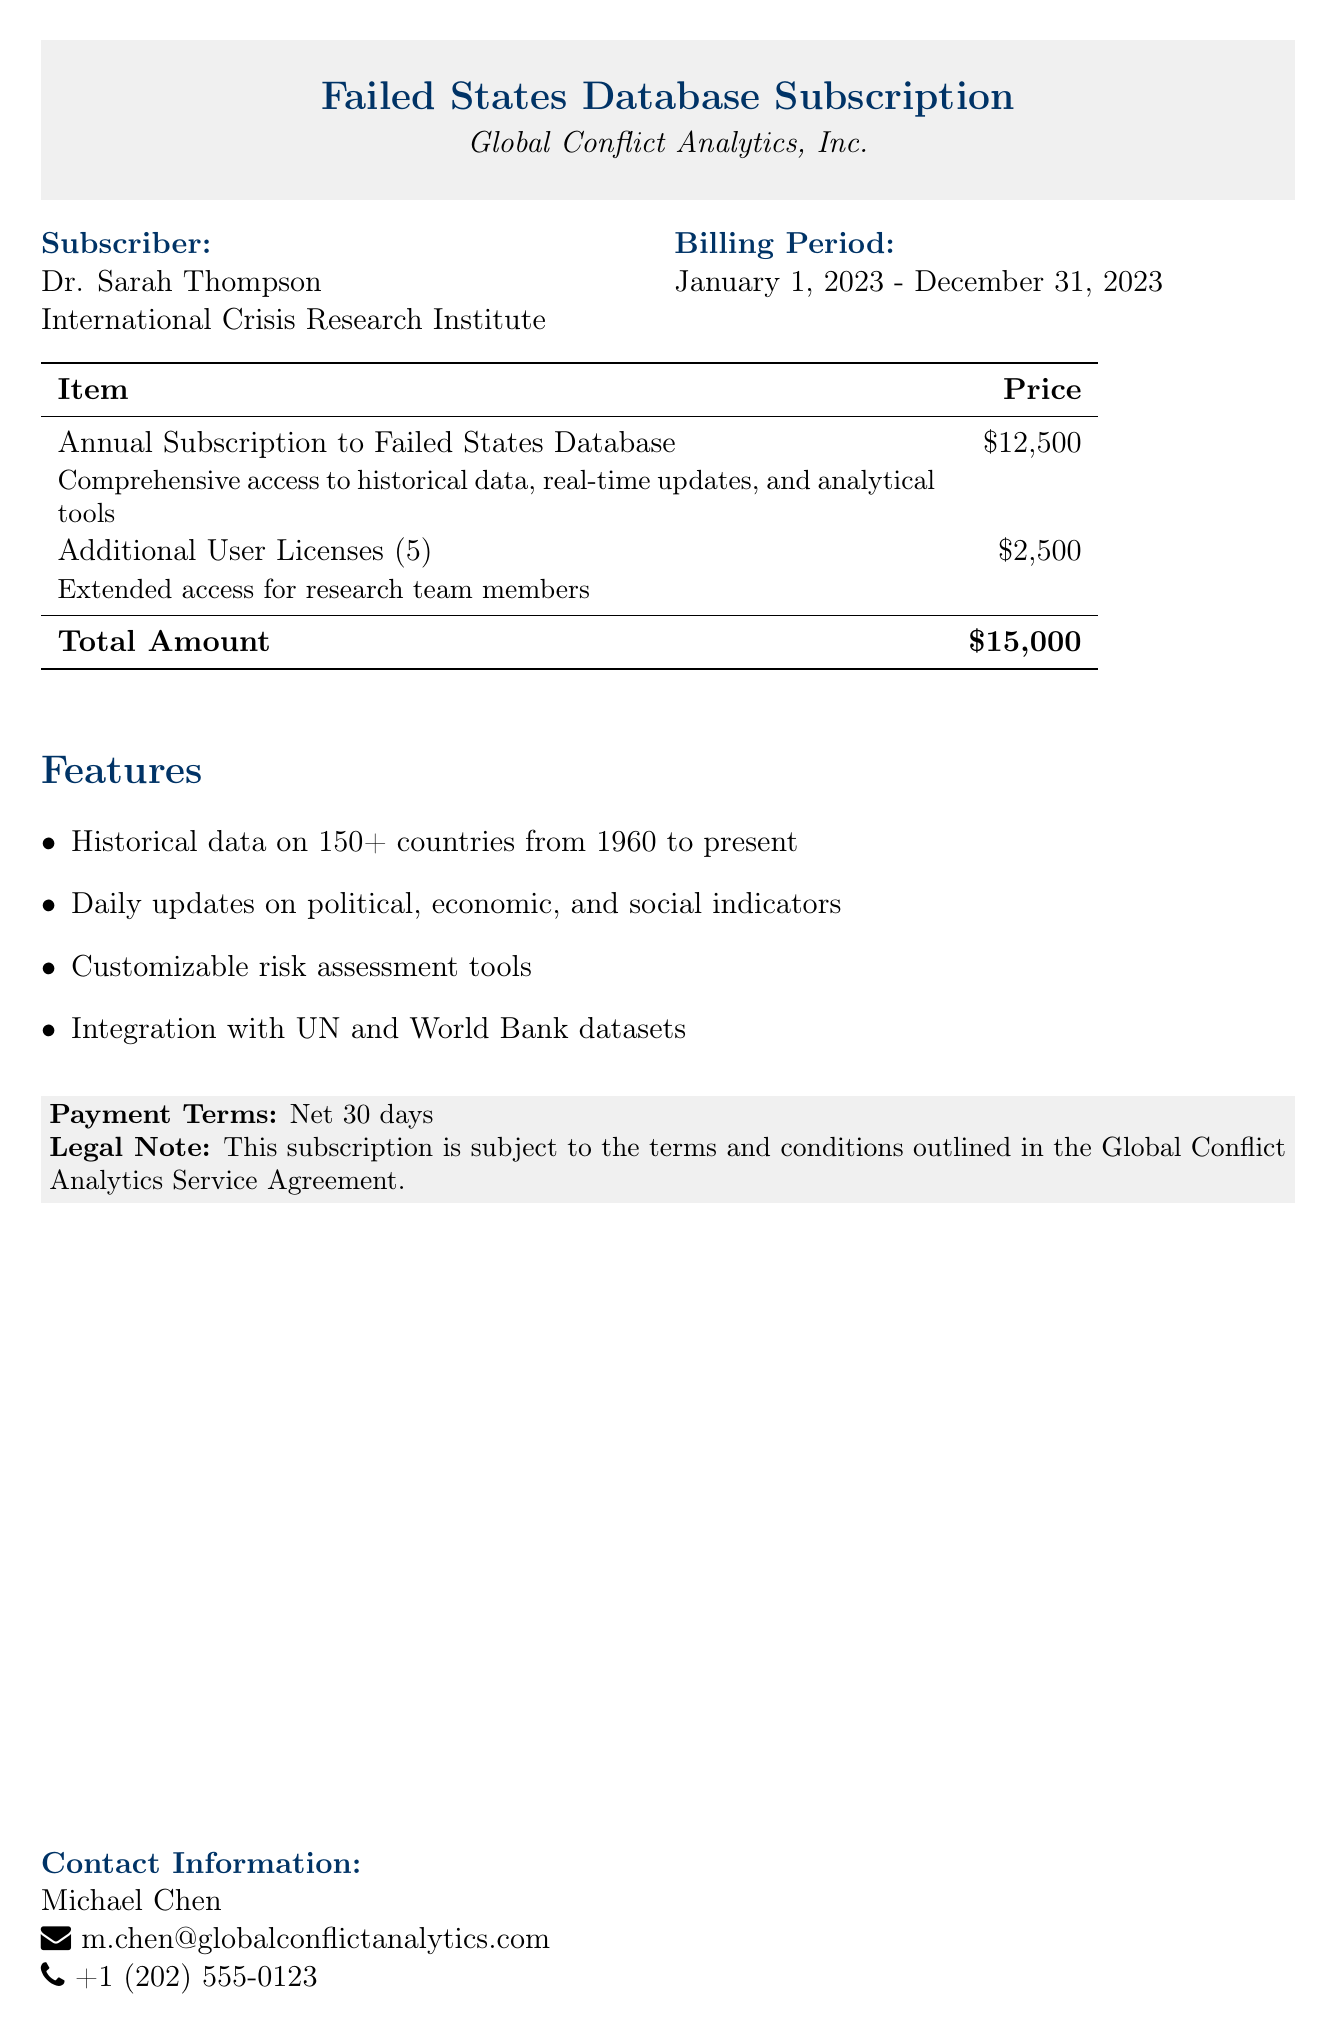What is the name of the subscriber? The subscriber's name is provided in the document as "Dr. Sarah Thompson".
Answer: Dr. Sarah Thompson What is the billing period for the subscription? The document specifies the billing period from "January 1, 2023" to "December 31, 2023".
Answer: January 1, 2023 - December 31, 2023 What is the total amount for the subscription? The total amount is listed as "$15,000".
Answer: $15,000 How many additional user licenses are included? The document states that there are "5" additional user licenses.
Answer: 5 What feature allows data integration with other datasets? The document mentions "Integration with UN and World Bank datasets" as a feature.
Answer: Integration with UN and World Bank datasets What is the price for the annual subscription? The annual subscription price is mentioned as "$12,500".
Answer: $12,500 What is the payment term specified in the document? The payment term noted is "Net 30 days".
Answer: Net 30 days Who can be contacted for more information? The document lists "Michael Chen" as the contact person for inquiries.
Answer: Michael Chen What is included with the comprehensive access? The comprehensive access includes "historical data, real-time updates, and analytical tools".
Answer: historical data, real-time updates, and analytical tools 